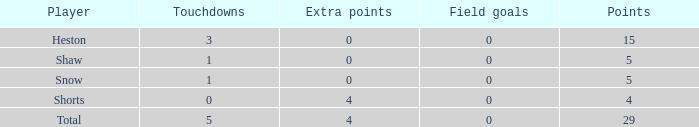What is the cumulative number of field goals a player obtained when there were in excess of 0 extra points and 5 touchdowns took place? 1.0. 